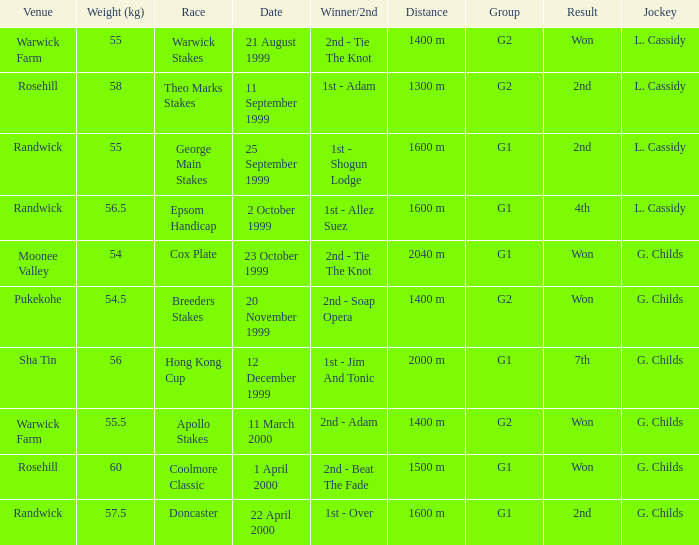List the weight for 56.5 kilograms. Epsom Handicap. 